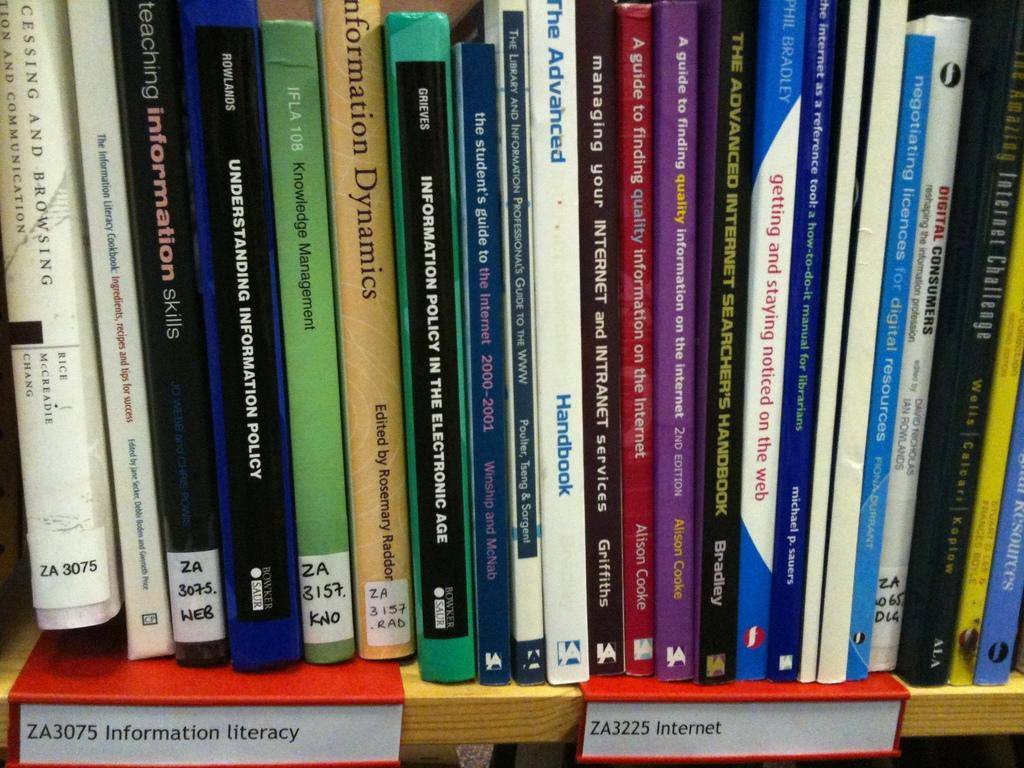<image>
Write a terse but informative summary of the picture. books on display on a shelf include the Advanced handbook 